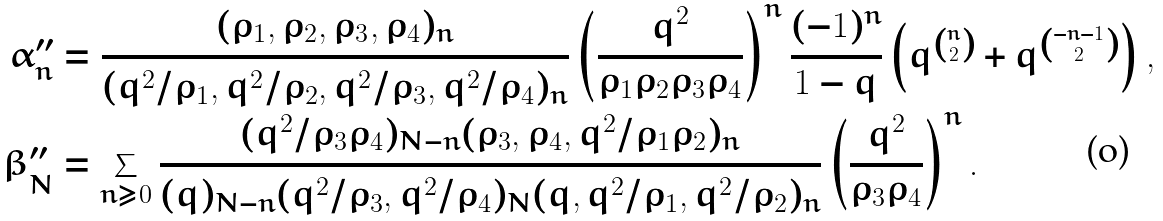Convert formula to latex. <formula><loc_0><loc_0><loc_500><loc_500>\alpha _ { n } ^ { \prime \prime } & = \frac { ( \rho _ { 1 } , \rho _ { 2 } , \rho _ { 3 } , \rho _ { 4 } ) _ { n } } { ( q ^ { 2 } / \rho _ { 1 } , q ^ { 2 } / \rho _ { 2 } , q ^ { 2 } / \rho _ { 3 } , q ^ { 2 } / \rho _ { 4 } ) _ { n } } \left ( \frac { q ^ { 2 } } { \rho _ { 1 } \rho _ { 2 } \rho _ { 3 } \rho _ { 4 } } \right ) ^ { n } \frac { ( - 1 ) ^ { n } } { 1 - q } \left ( q ^ { n \choose 2 } + q ^ { - n - 1 \choose 2 } \right ) , \\ \beta _ { N } ^ { \prime \prime } & = \sum _ { n \geq 0 } \frac { ( q ^ { 2 } / \rho _ { 3 } \rho _ { 4 } ) _ { N - n } ( \rho _ { 3 } , \rho _ { 4 } , q ^ { 2 } / \rho _ { 1 } \rho _ { 2 } ) _ { n } } { ( q ) _ { N - n } ( q ^ { 2 } / \rho _ { 3 } , q ^ { 2 } / \rho _ { 4 } ) _ { N } ( q , q ^ { 2 } / \rho _ { 1 } , q ^ { 2 } / \rho _ { 2 } ) _ { n } } \left ( \frac { q ^ { 2 } } { \rho _ { 3 } \rho _ { 4 } } \right ) ^ { n } .</formula> 